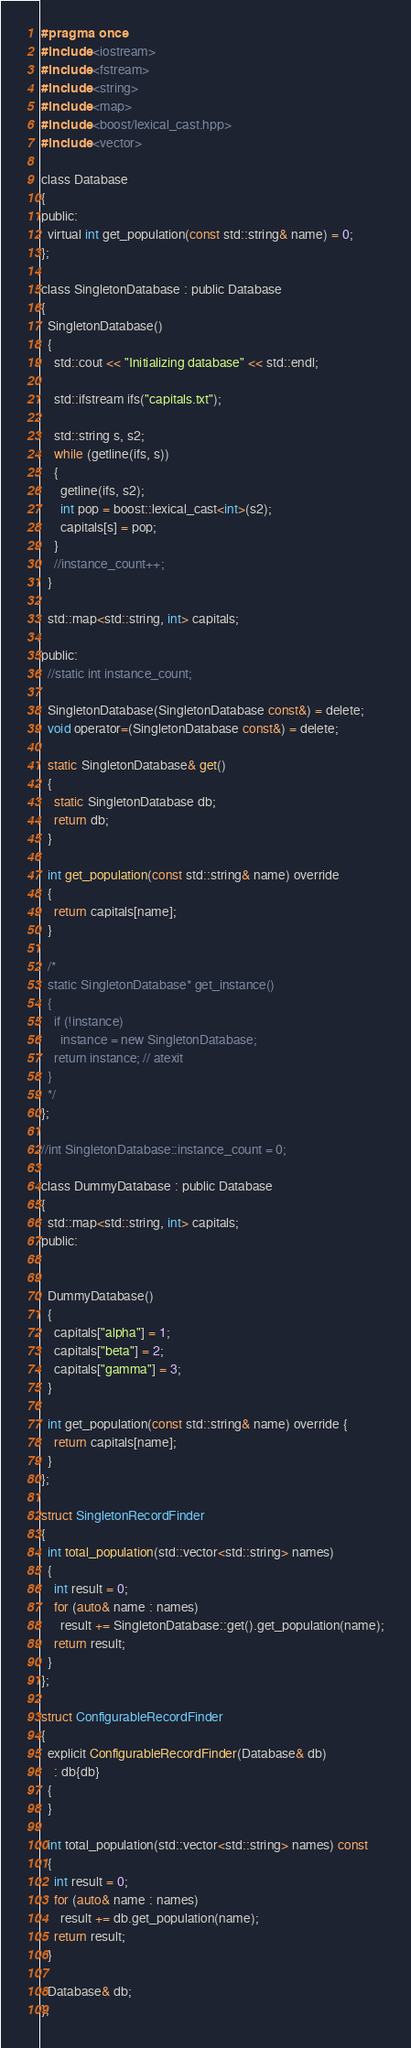<code> <loc_0><loc_0><loc_500><loc_500><_C_>#pragma once
#include <iostream>
#include <fstream>
#include <string>
#include <map>
#include <boost/lexical_cast.hpp>
#include <vector>

class Database
{
public:
  virtual int get_population(const std::string& name) = 0;
};

class SingletonDatabase : public Database
{
  SingletonDatabase()
  {
    std::cout << "Initializing database" << std::endl;

    std::ifstream ifs("capitals.txt");

    std::string s, s2;
    while (getline(ifs, s))
    {
      getline(ifs, s2);
      int pop = boost::lexical_cast<int>(s2);
      capitals[s] = pop;
    }
    //instance_count++;
  }

  std::map<std::string, int> capitals;

public:
  //static int instance_count;

  SingletonDatabase(SingletonDatabase const&) = delete;
  void operator=(SingletonDatabase const&) = delete;

  static SingletonDatabase& get()
  {
    static SingletonDatabase db;
    return db;
  }

  int get_population(const std::string& name) override
  {
    return capitals[name];
  }

  /*
  static SingletonDatabase* get_instance()
  {
    if (!instance)
      instance = new SingletonDatabase;
    return instance; // atexit
  }
  */
};

//int SingletonDatabase::instance_count = 0;

class DummyDatabase : public Database
{
  std::map<std::string, int> capitals;
public:


  DummyDatabase()
  {
    capitals["alpha"] = 1;
    capitals["beta"] = 2;
    capitals["gamma"] = 3;
  }

  int get_population(const std::string& name) override {
    return capitals[name];
  }
};

struct SingletonRecordFinder
{
  int total_population(std::vector<std::string> names)
  {
    int result = 0;
    for (auto& name : names)
      result += SingletonDatabase::get().get_population(name);
    return result;
  }
};

struct ConfigurableRecordFinder
{
  explicit ConfigurableRecordFinder(Database& db)
    : db{db}
  {
  }

  int total_population(std::vector<std::string> names) const
  {
    int result = 0;
    for (auto& name : names)
      result += db.get_population(name);
    return result;
  }

  Database& db;
};</code> 